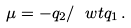Convert formula to latex. <formula><loc_0><loc_0><loc_500><loc_500>\mu = - q _ { 2 } / \ w t { q } _ { 1 } \, .</formula> 